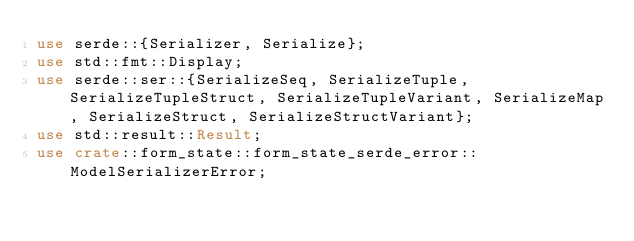Convert code to text. <code><loc_0><loc_0><loc_500><loc_500><_Rust_>use serde::{Serializer, Serialize};
use std::fmt::Display;
use serde::ser::{SerializeSeq, SerializeTuple, SerializeTupleStruct, SerializeTupleVariant, SerializeMap, SerializeStruct, SerializeStructVariant};
use std::result::Result;
use crate::form_state::form_state_serde_error::ModelSerializerError;
</code> 